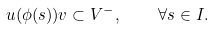<formula> <loc_0><loc_0><loc_500><loc_500>u ( \phi ( s ) ) v \subset V ^ { - } , \quad \forall s \in I .</formula> 